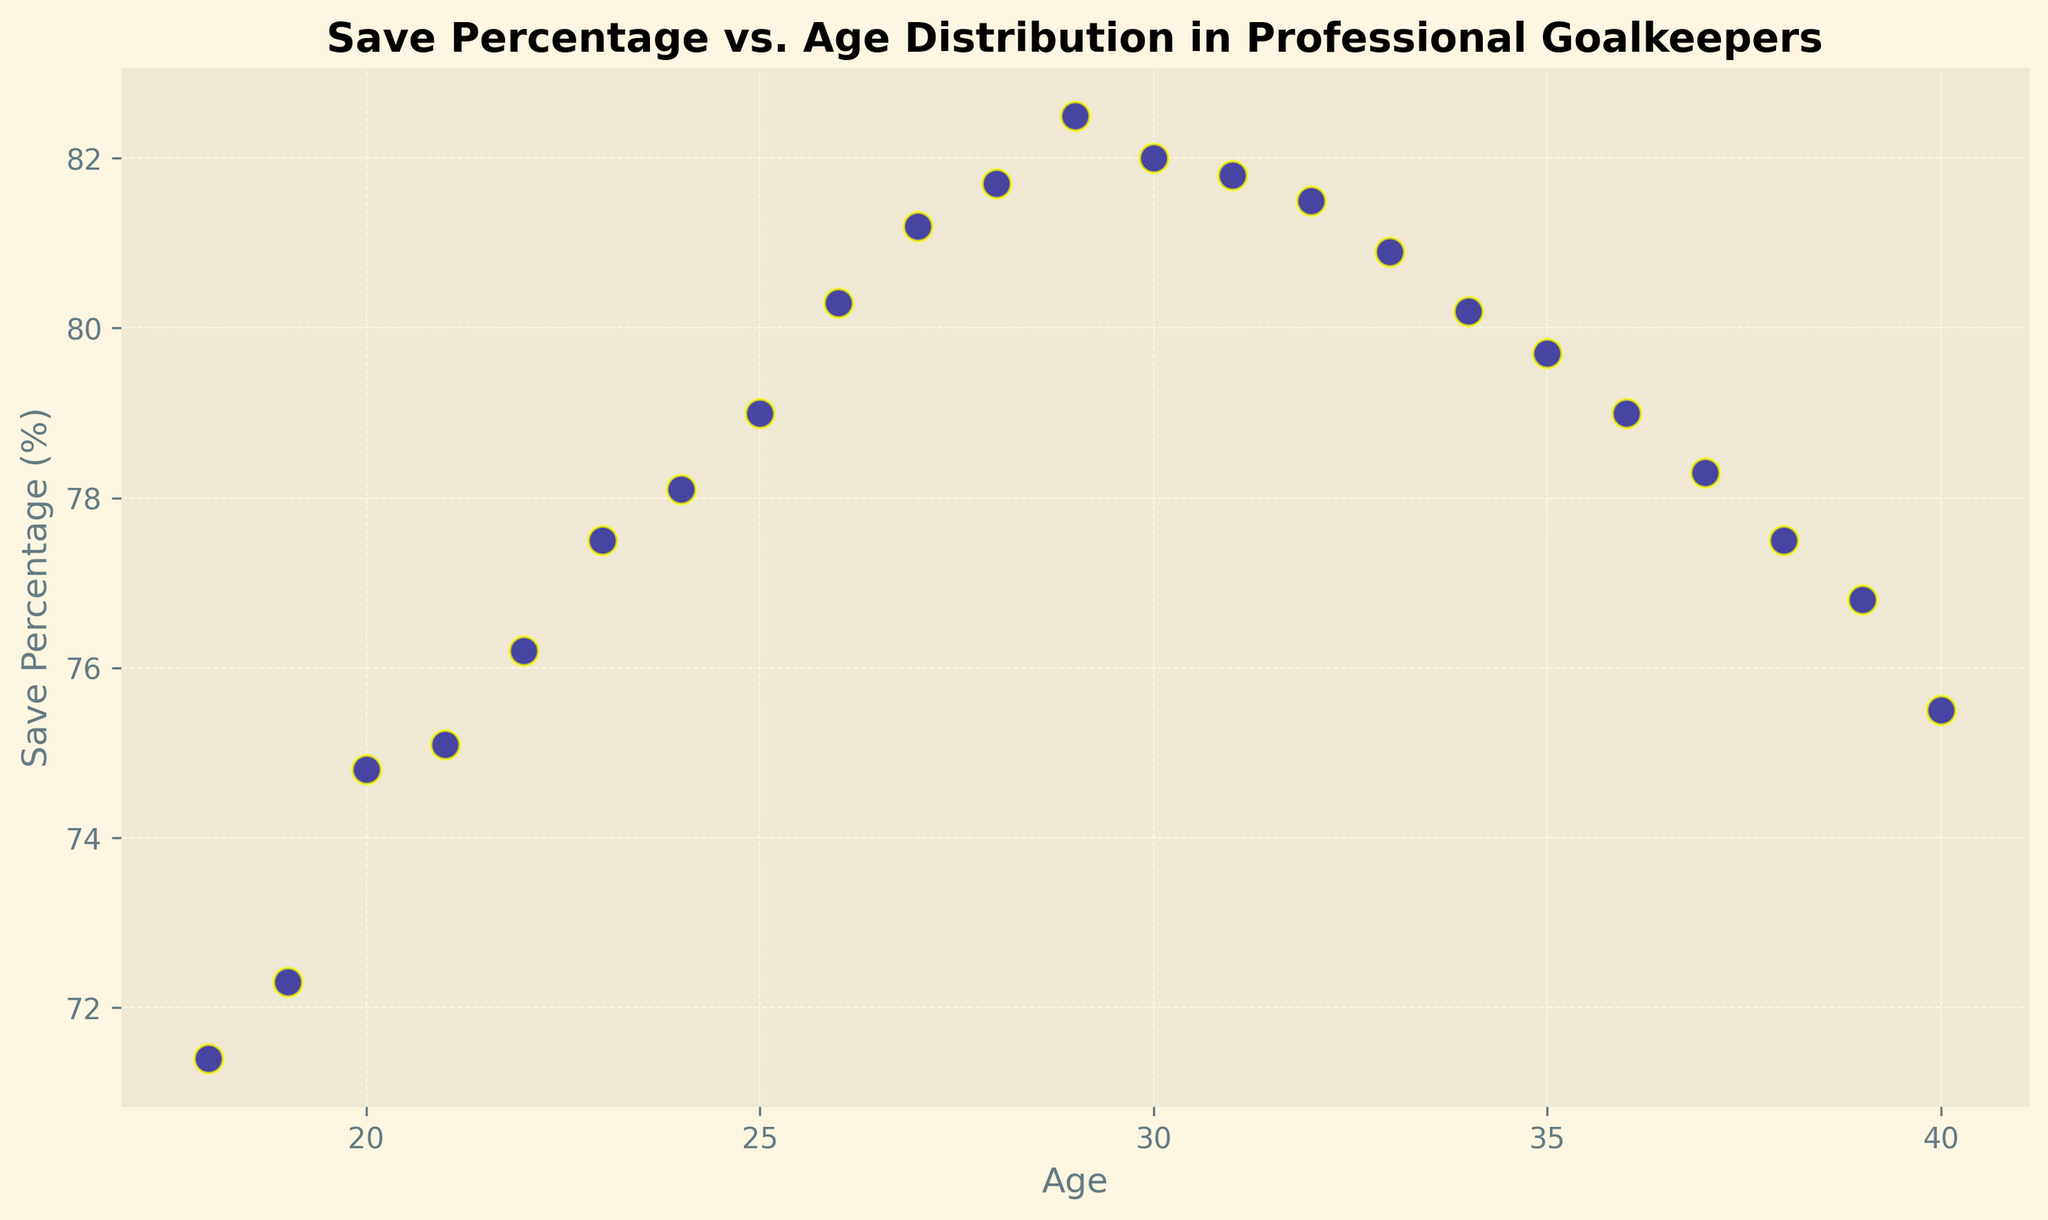What age corresponds to the highest save percentage? By examining the scatter plot, find the data point with the highest vertical position. The highest save percentage is at the age of 29.
Answer: 29 What is the trend in save percentages from the ages of 18 to 29? Observe the scatter plot points from age 18 to age 29; the save percentage shows a steady increase as age advances.
Answer: Increasing At what age does save percentage start to decline after peaking? Identify the highest save percentage (at age 29) and look at subsequent points. The save percentage begins to decline after the age of 29.
Answer: 30 How much does the save percentage change between ages 20 and 30? Locate data points for ages 20 and 30. The save percentage at age 20 is 74.8%, and at age 30, it is 82.0%. The change is 82.0% - 74.8% = 7.2%.
Answer: 7.2% Which age group (20-25 or 35-40) has a higher average save percentage? Calculate the average save percentage for ages 20-25 and 35-40 separately. For ages 20-25, average = (74.8 + 75.1 + 76.2 + 77.5 + 78.1 + 79.0)/6 = 76.12%. For ages 35-40, average = (79.7 + 79.0 + 78.3 + 77.5 + 76.8 + 75.5)/6 = 77.8%.
Answer: 35-40 Is there a significant difference in save percentages between goalkeepers under 25 and those over 25? Compare the save percentages of goalkeepers under 25 (ages 18-24) and those over 25 (ages 26-40). Goalkeepers under 25: range between 71.4% and 79.0%; those over 25: range between 79.0% and 82.5%, indicating that save percentages generally improve with age.
Answer: Yes, significant Around what age might goalkeepers experience the highest consistency in their save percentages? Identify the age range where the save percentages exhibit the least fluctuation. Between ages 27 and 33, the save percentage fluctuates minimally around 80-82%.
Answer: 27-33 